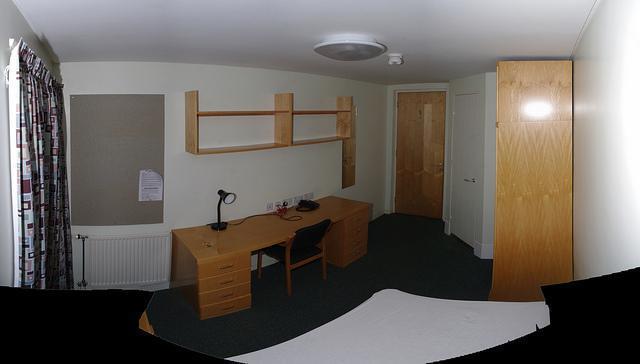How many doors are in this room?
Give a very brief answer. 2. 